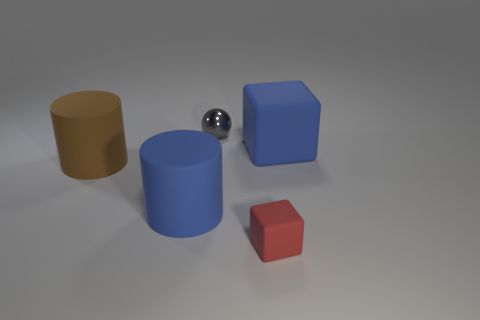There is a big thing to the right of the tiny red rubber cube; is its color the same as the cylinder right of the big brown thing?
Offer a terse response. Yes. What number of tiny gray balls are to the right of the brown thing?
Keep it short and to the point. 1. There is a object that is behind the large rubber object right of the gray sphere; is there a large object to the right of it?
Your answer should be very brief. Yes. How many blue matte cubes are the same size as the brown rubber object?
Your answer should be compact. 1. There is a blue object right of the big blue cylinder behind the small matte block; what is its material?
Offer a terse response. Rubber. What shape is the big blue object on the right side of the cube that is in front of the cylinder that is on the right side of the large brown cylinder?
Give a very brief answer. Cube. Does the big blue rubber thing to the left of the small gray shiny object have the same shape as the large matte thing that is left of the large blue matte cylinder?
Your answer should be very brief. Yes. How many other things are made of the same material as the red thing?
Offer a very short reply. 3. What is the shape of the large brown thing that is the same material as the blue block?
Make the answer very short. Cylinder. Do the gray metal ball and the blue cylinder have the same size?
Offer a very short reply. No. 